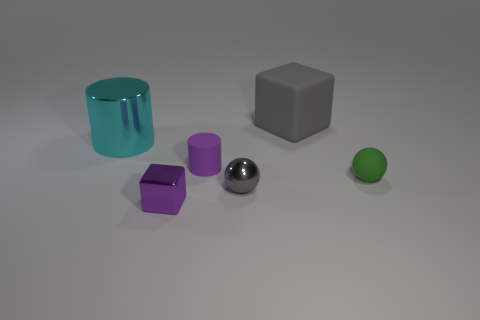Is the color of the metallic sphere the same as the rubber block?
Your response must be concise. Yes. Are there more large cyan cylinders to the right of the tiny purple shiny cube than green matte balls?
Provide a succinct answer. No. There is a rubber block on the right side of the large cylinder; what number of purple rubber cylinders are in front of it?
Give a very brief answer. 1. Does the cube in front of the big gray block have the same material as the gray thing in front of the big gray block?
Keep it short and to the point. Yes. There is a tiny object that is the same color as the tiny cube; what material is it?
Give a very brief answer. Rubber. What number of cyan metal things are the same shape as the tiny gray metallic object?
Offer a very short reply. 0. Is the material of the small cylinder the same as the gray thing that is on the left side of the large gray cube?
Provide a short and direct response. No. There is another ball that is the same size as the gray metal ball; what is it made of?
Offer a very short reply. Rubber. Is there a metallic ball of the same size as the gray block?
Ensure brevity in your answer.  No. What is the shape of the gray thing that is the same size as the green thing?
Your answer should be very brief. Sphere. 